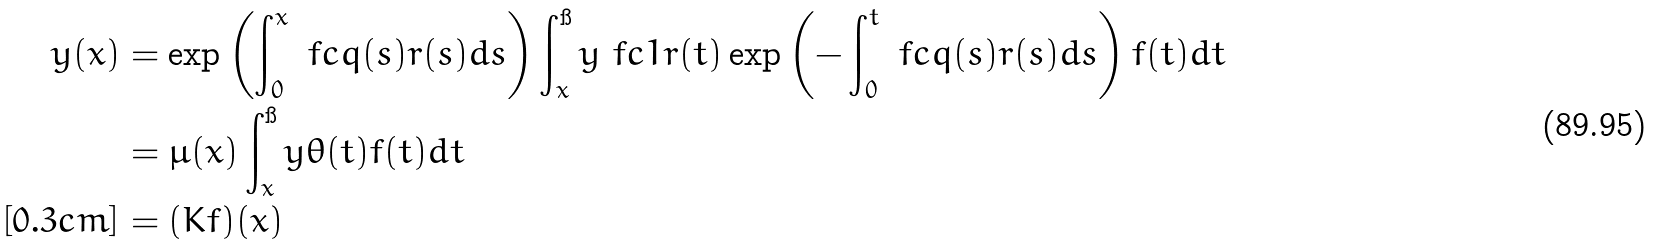<formula> <loc_0><loc_0><loc_500><loc_500>y ( x ) & = \exp \left ( \int _ { 0 } ^ { x } \ f c { q ( s ) } { r ( s ) } d s \right ) \int _ { x } ^ { \i } y \ f c { 1 } { r ( t ) } \exp \left ( - \int _ { 0 } ^ { t } \ f c { q ( s ) } { r ( s ) } d s \right ) f ( t ) d t \\ & = \mu ( x ) \int _ { x } ^ { \i } y \theta ( t ) f ( t ) d t \\ [ 0 . 3 c m ] & = ( K f ) ( x )</formula> 